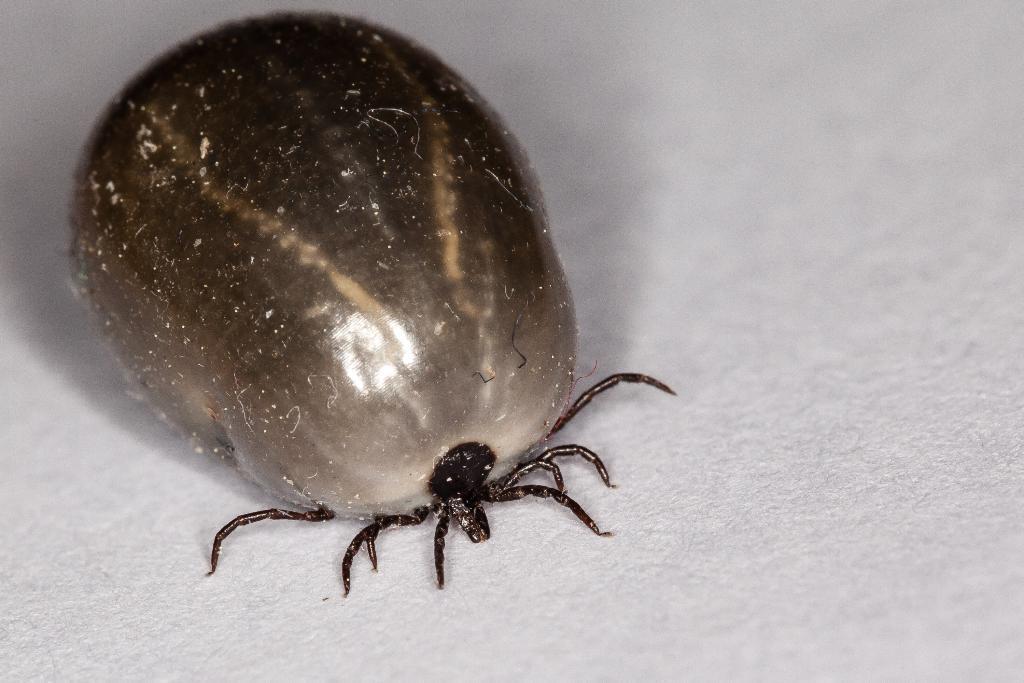Describe this image in one or two sentences. In this image we can see an insect and the background is white. 